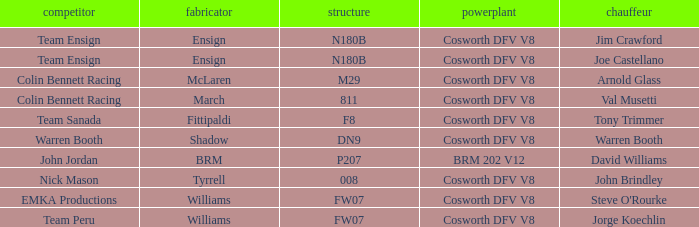Who built Warren Booth's car with the Cosworth DFV V8 engine? Shadow. 